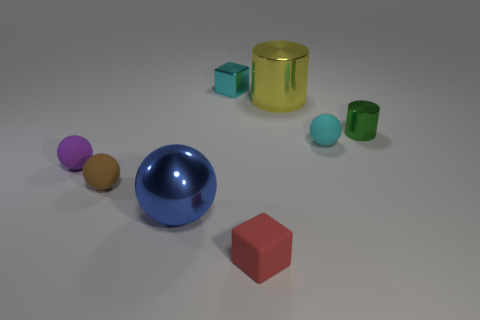Subtract 1 spheres. How many spheres are left? 3 Add 1 tiny green shiny cylinders. How many objects exist? 9 Subtract all cubes. How many objects are left? 6 Subtract 1 purple balls. How many objects are left? 7 Subtract all shiny objects. Subtract all brown rubber objects. How many objects are left? 3 Add 2 small brown rubber balls. How many small brown rubber balls are left? 3 Add 1 large objects. How many large objects exist? 3 